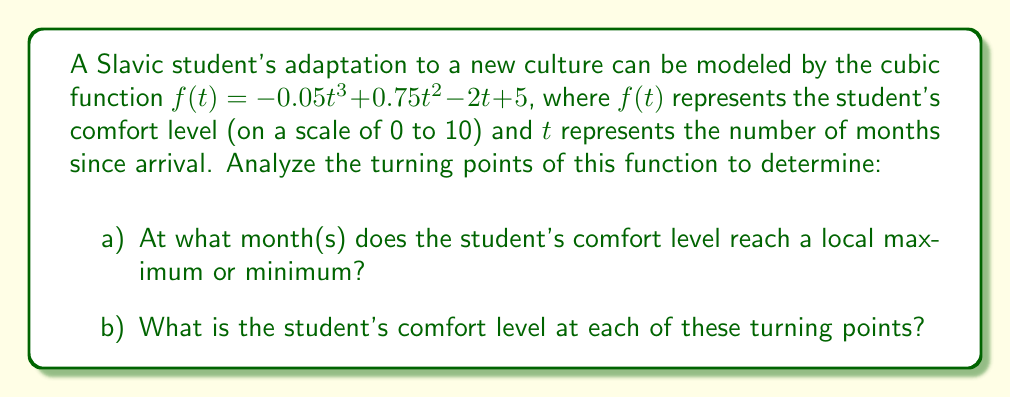Give your solution to this math problem. To find the turning points of the cubic function, we need to follow these steps:

1) First, find the derivative of the function:
   $f'(t) = -0.15t^2 + 1.5t - 2$

2) Set the derivative equal to zero and solve for t:
   $-0.15t^2 + 1.5t - 2 = 0$

3) This is a quadratic equation. We can solve it using the quadratic formula:
   $t = \frac{-b \pm \sqrt{b^2 - 4ac}}{2a}$

   Where $a = -0.15$, $b = 1.5$, and $c = -2$

4) Plugging these values into the quadratic formula:
   $t = \frac{-1.5 \pm \sqrt{1.5^2 - 4(-0.15)(-2)}}{2(-0.15)}$
   $= \frac{-1.5 \pm \sqrt{2.25 - 1.2}}{-0.3}$
   $= \frac{-1.5 \pm \sqrt{1.05}}{-0.3}$
   $= \frac{-1.5 \pm 1.025}{-0.3}$

5) This gives us two solutions:
   $t_1 = \frac{-1.5 + 1.025}{-0.3} \approx 1.58$ months
   $t_2 = \frac{-1.5 - 1.025}{-0.3} \approx 8.42$ months

6) To determine if these are maximums or minimums, we can check the second derivative:
   $f''(t) = -0.3t + 1.5$

   At $t_1 = 1.58$: $f''(1.58) = -0.3(1.58) + 1.5 \approx 1.026 > 0$, so this is a local minimum.
   At $t_2 = 8.42$: $f''(8.42) = -0.3(8.42) + 1.5 \approx -1.026 < 0$, so this is a local maximum.

7) To find the comfort levels at these points, we plug these t-values back into the original function:
   At $t_1 = 1.58$: $f(1.58) \approx 3.37$
   At $t_2 = 8.42$: $f(8.42) \approx 7.63$
Answer: a) The student's comfort level reaches a local minimum at approximately 1.58 months and a local maximum at approximately 8.42 months after arrival.
b) The comfort levels at these turning points are approximately 3.37 (minimum) and 7.63 (maximum) respectively. 